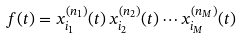Convert formula to latex. <formula><loc_0><loc_0><loc_500><loc_500>f ( t ) = x _ { i _ { 1 } } ^ { ( n _ { 1 } ) } ( t ) \, x _ { i _ { 2 } } ^ { ( n _ { 2 } ) } ( t ) \cdots x _ { i _ { M } } ^ { ( n _ { M } ) } ( t )</formula> 